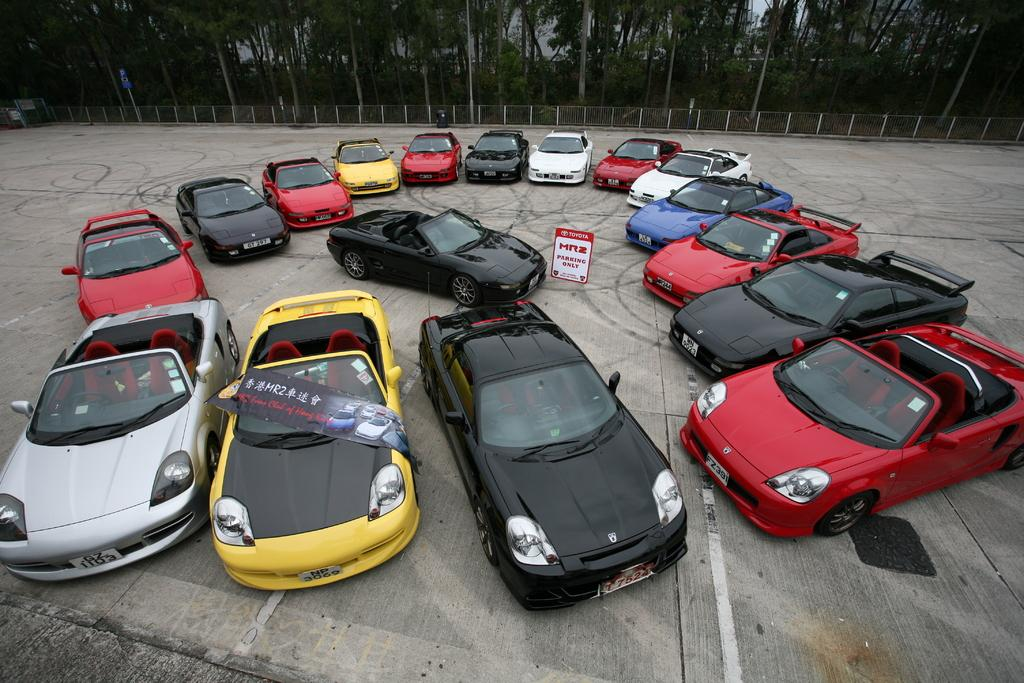What is located in the center of the image? There are cars and a board in the center of the image. What can be seen on the board? The facts do not specify what is on the board, so we cannot answer that question definitively. What is visible in the background of the picture? There is a mesh and trees in the background of the image. What is the surface on which the cars and board are placed? There is a ground at the bottom of the image. What type of design can be seen on the pan in the image? There is no pan present in the image, so we cannot answer that question. 